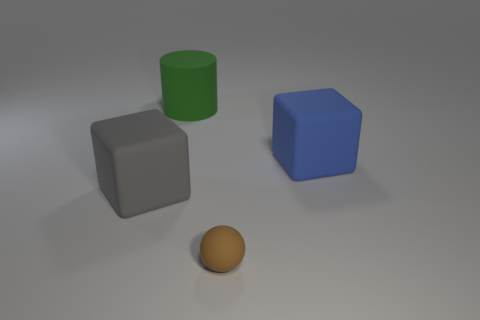Considering the organization of the objects in the image, is there any discernible pattern or arrangement? The objects are arranged with some space between them, without any overt pattern. They seem to be deliberately placed to not overlap in the visual plane, which allows each object's size, color, and texture to be clearly observed. The arrangement might suggest an intention to present each object distinctly, perhaps for an instructive display or a comparative analysis. 